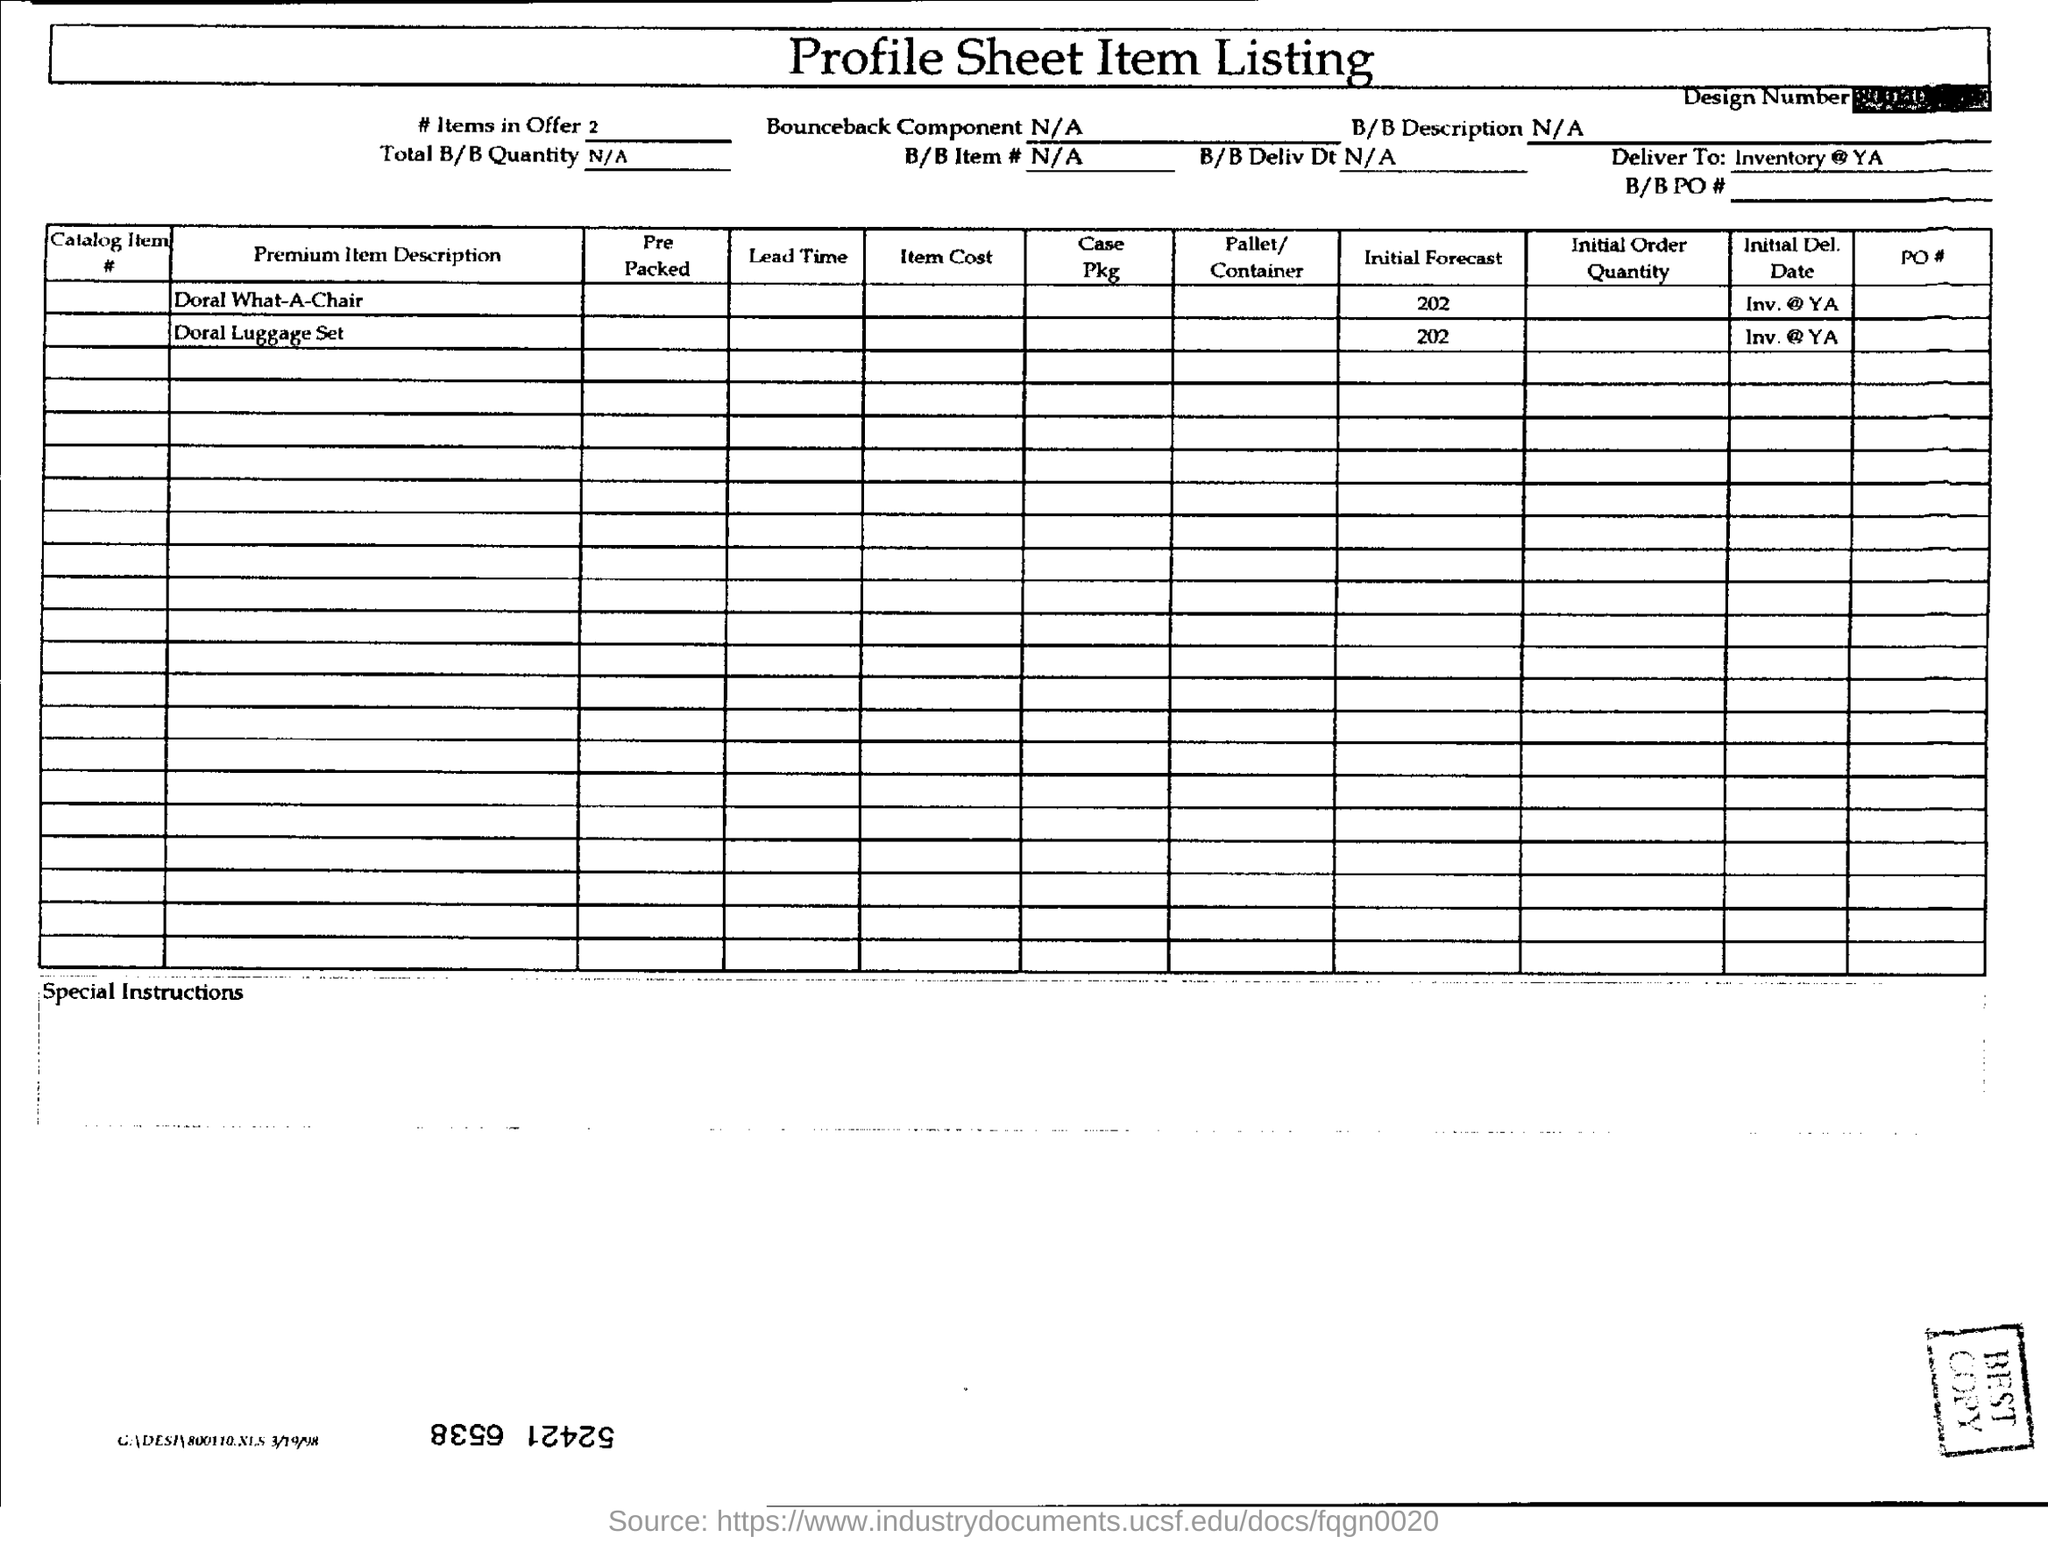Point out several critical features in this image. This document is titled a 'profile sheet item listing.' 